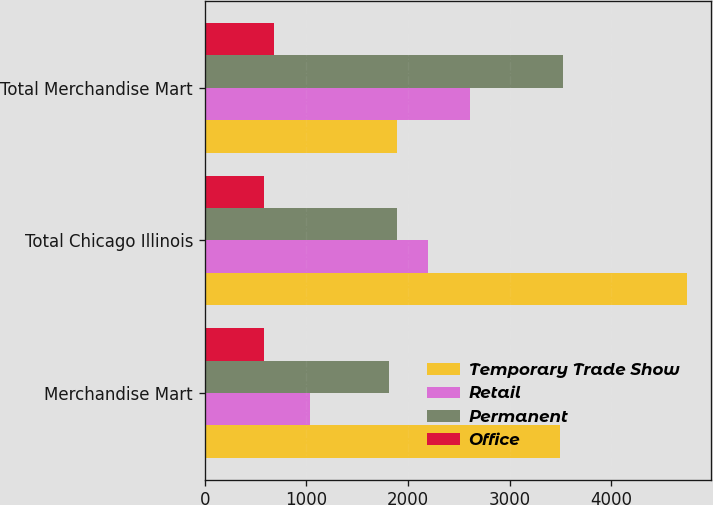Convert chart to OTSL. <chart><loc_0><loc_0><loc_500><loc_500><stacked_bar_chart><ecel><fcel>Merchandise Mart<fcel>Total Chicago Illinois<fcel>Total Merchandise Mart<nl><fcel>Temporary Trade Show<fcel>3492<fcel>4744<fcel>1893<nl><fcel>Retail<fcel>1033<fcel>2192<fcel>2608<nl><fcel>Permanent<fcel>1810<fcel>1893<fcel>3521<nl><fcel>Office<fcel>582<fcel>582<fcel>683<nl></chart> 